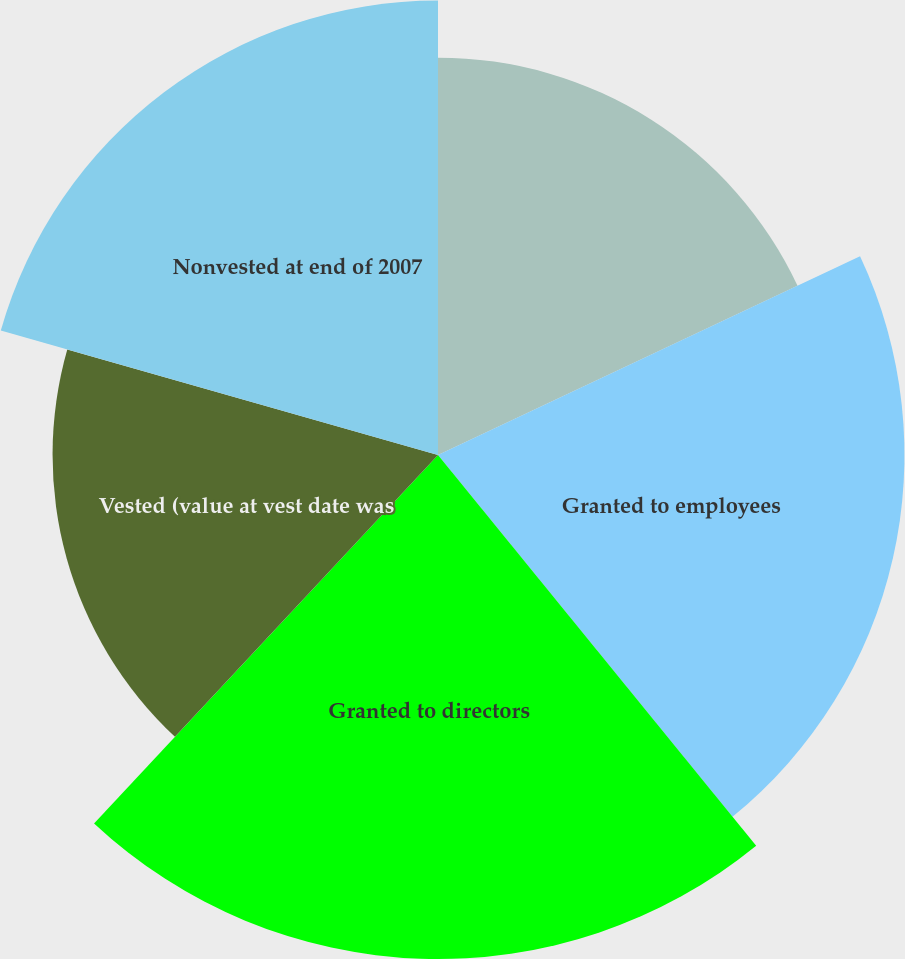<chart> <loc_0><loc_0><loc_500><loc_500><pie_chart><fcel>Nonvested at beginning of 2007<fcel>Granted to employees<fcel>Granted to directors<fcel>Vested (value at vest date was<fcel>Nonvested at end of 2007<nl><fcel>18.0%<fcel>21.13%<fcel>22.83%<fcel>17.46%<fcel>20.59%<nl></chart> 